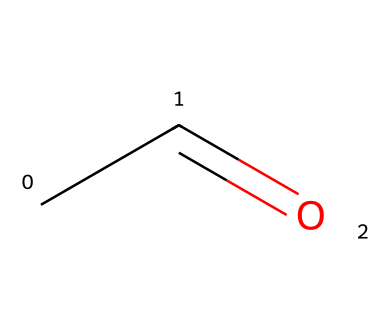How many carbon atoms are in acetaldehyde? The SMILES representation "CC=O" indicates that there are two carbon atoms present, as each "C" represents one carbon atom.
Answer: 2 What functional group is represented in acetaldehyde? The "C=O" portion of the SMILES indicates a carbonyl group, which is characteristic of aldehydes.
Answer: carbonyl How many hydrogen atoms are in acetaldehyde? The structure CC=O shows that the first carbon is connected to three hydrogen atoms (CH3-) and the second carbon (which is part of the carbonyl) is connected to one hydrogen, resulting in a total of four hydrogen atoms.
Answer: 4 Is acetaldehyde classified as a saturated or unsaturated compound? The presence of the double bond between the carbon and oxygen (C=O) and the single bonds in the rest of the structure suggests that acetaldehyde is an unsaturated compound.
Answer: unsaturated What is the molecular formula for acetaldehyde? From the SMILES representation, there are 2 carbon (C), 4 hydrogen (H), and 1 oxygen (O) atoms, which gives the molecular formula C2H4O.
Answer: C2H4O What type of reaction is commonly associated with aldehydes like acetaldehyde in disinfectants? Aldehydes can undergo oxidation reactions, leading to the formation of carboxylic acids, which may be relevant in the disinfection process.
Answer: oxidation What is the significance of the carbonyl group in acetaldehyde? The carbonyl group (C=O) is reactive and is responsible for many chemical properties of aldehydes, including their ability to act as disinfectants due to reactivity with various pathogens.
Answer: reactivity 